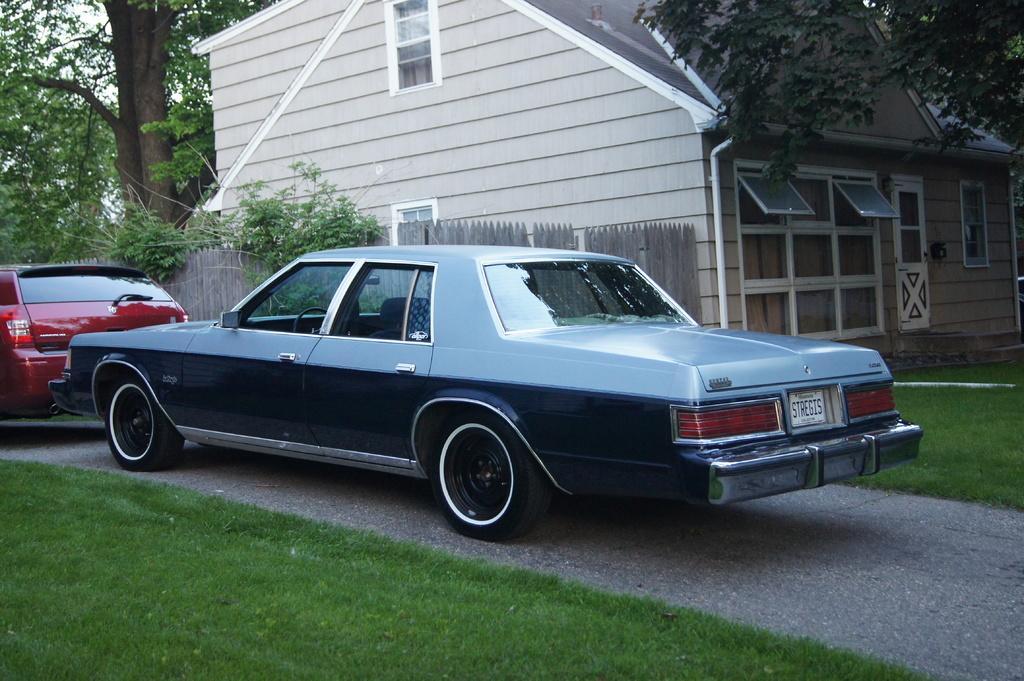How many vehicles are present on the road in the image? There are two vehicles on the road in the image. What can be seen behind the vehicles? There are trees, a fence, and a house behind the vehicles. What is visible in the sky in the image? The sky is visible in the image. What type of ground is present at the bottom of the image? There is grass at the bottom of the image. What is the belief of the grass in the image? The grass in the image does not have any beliefs, as it is a non-living object. 